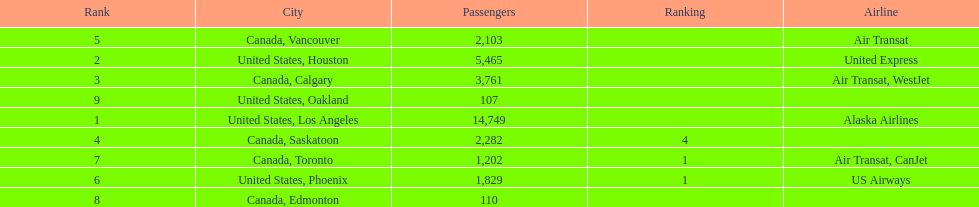How many airlines have a steady ranking? 4. 